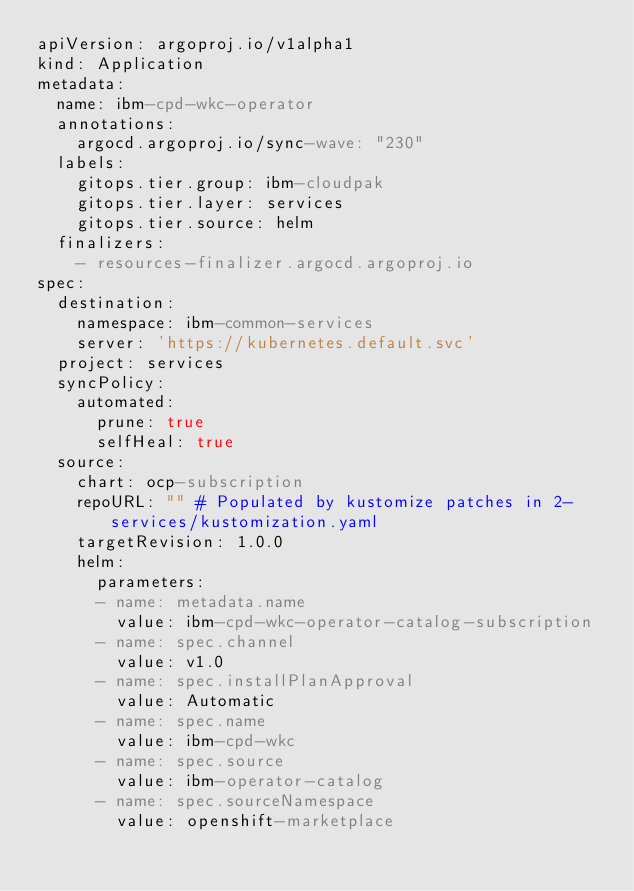<code> <loc_0><loc_0><loc_500><loc_500><_YAML_>apiVersion: argoproj.io/v1alpha1
kind: Application
metadata:
  name: ibm-cpd-wkc-operator
  annotations:
    argocd.argoproj.io/sync-wave: "230"
  labels:
    gitops.tier.group: ibm-cloudpak
    gitops.tier.layer: services
    gitops.tier.source: helm
  finalizers:
    - resources-finalizer.argocd.argoproj.io
spec:
  destination:
    namespace: ibm-common-services
    server: 'https://kubernetes.default.svc'
  project: services
  syncPolicy:
    automated:
      prune: true
      selfHeal: true
  source:
    chart: ocp-subscription
    repoURL: "" # Populated by kustomize patches in 2-services/kustomization.yaml
    targetRevision: 1.0.0
    helm:
      parameters:
      - name: metadata.name
        value: ibm-cpd-wkc-operator-catalog-subscription
      - name: spec.channel
        value: v1.0
      - name: spec.installPlanApproval
        value: Automatic
      - name: spec.name
        value: ibm-cpd-wkc
      - name: spec.source
        value: ibm-operator-catalog
      - name: spec.sourceNamespace
        value: openshift-marketplace</code> 